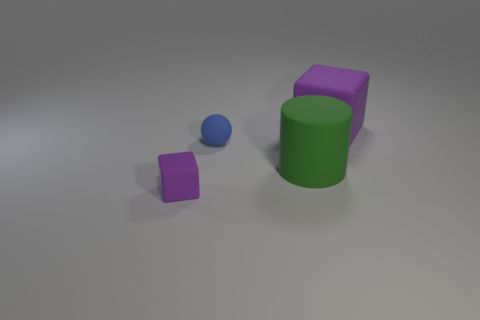Add 2 big yellow cylinders. How many objects exist? 6 Subtract all cylinders. How many objects are left? 3 Add 2 blue rubber objects. How many blue rubber objects are left? 3 Add 4 blue matte blocks. How many blue matte blocks exist? 4 Subtract 0 cyan spheres. How many objects are left? 4 Subtract all large rubber objects. Subtract all spheres. How many objects are left? 1 